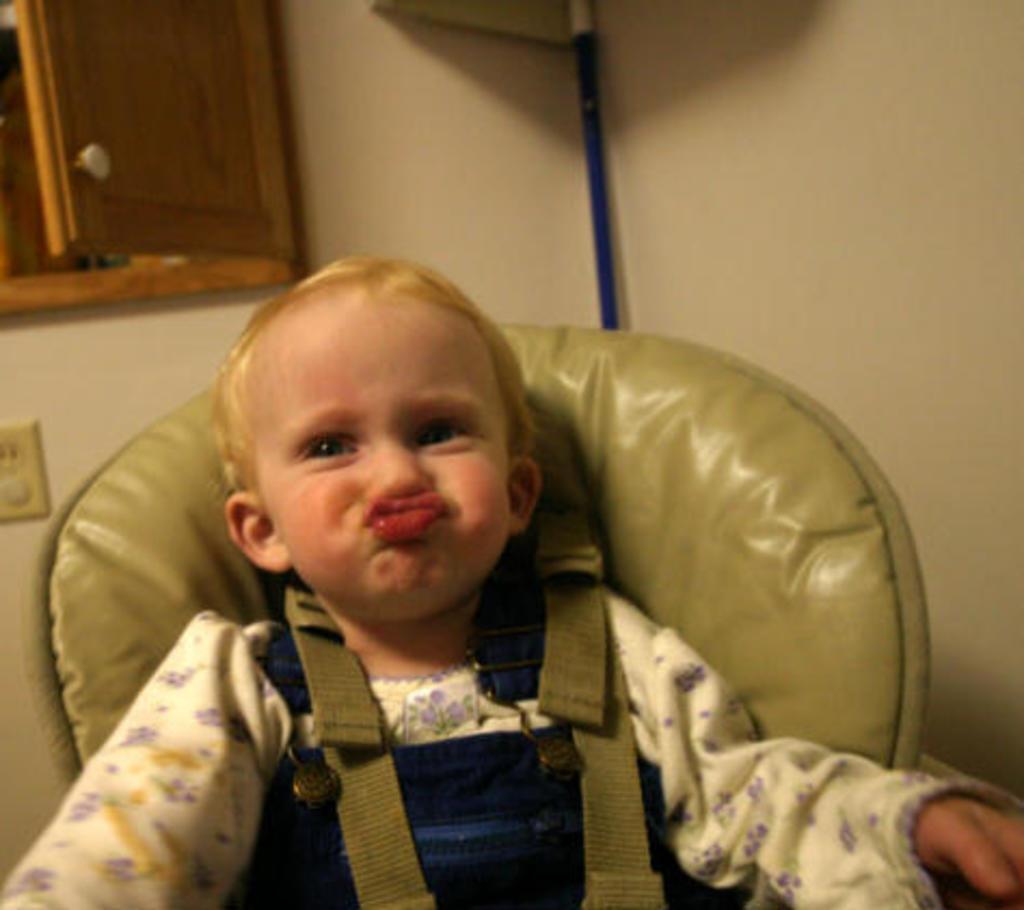How would you summarize this image in a sentence or two? In this picture we can see a kid is sitting on a chair, in the background there is a wall, there is a cupboard at the left top of the picture. 